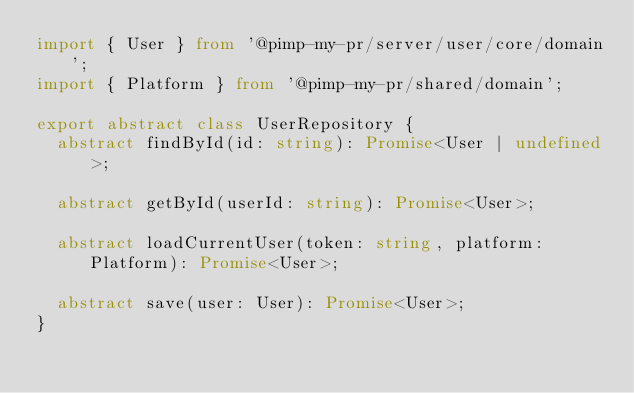Convert code to text. <code><loc_0><loc_0><loc_500><loc_500><_TypeScript_>import { User } from '@pimp-my-pr/server/user/core/domain';
import { Platform } from '@pimp-my-pr/shared/domain';

export abstract class UserRepository {
  abstract findById(id: string): Promise<User | undefined>;

  abstract getById(userId: string): Promise<User>;

  abstract loadCurrentUser(token: string, platform: Platform): Promise<User>;

  abstract save(user: User): Promise<User>;
}
</code> 